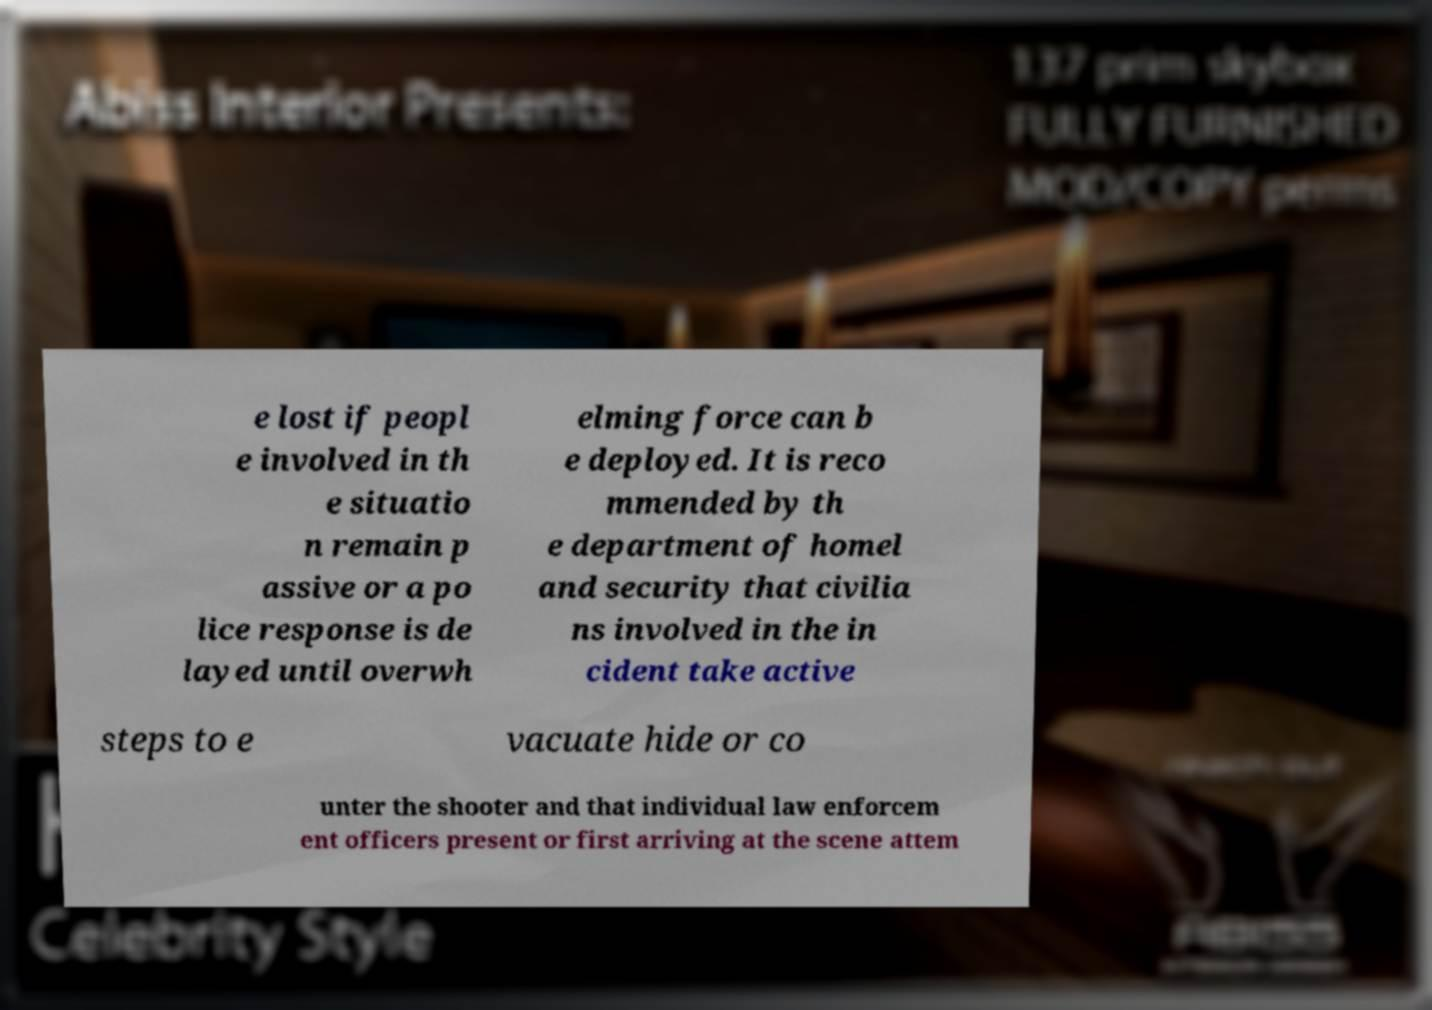Could you extract and type out the text from this image? e lost if peopl e involved in th e situatio n remain p assive or a po lice response is de layed until overwh elming force can b e deployed. It is reco mmended by th e department of homel and security that civilia ns involved in the in cident take active steps to e vacuate hide or co unter the shooter and that individual law enforcem ent officers present or first arriving at the scene attem 